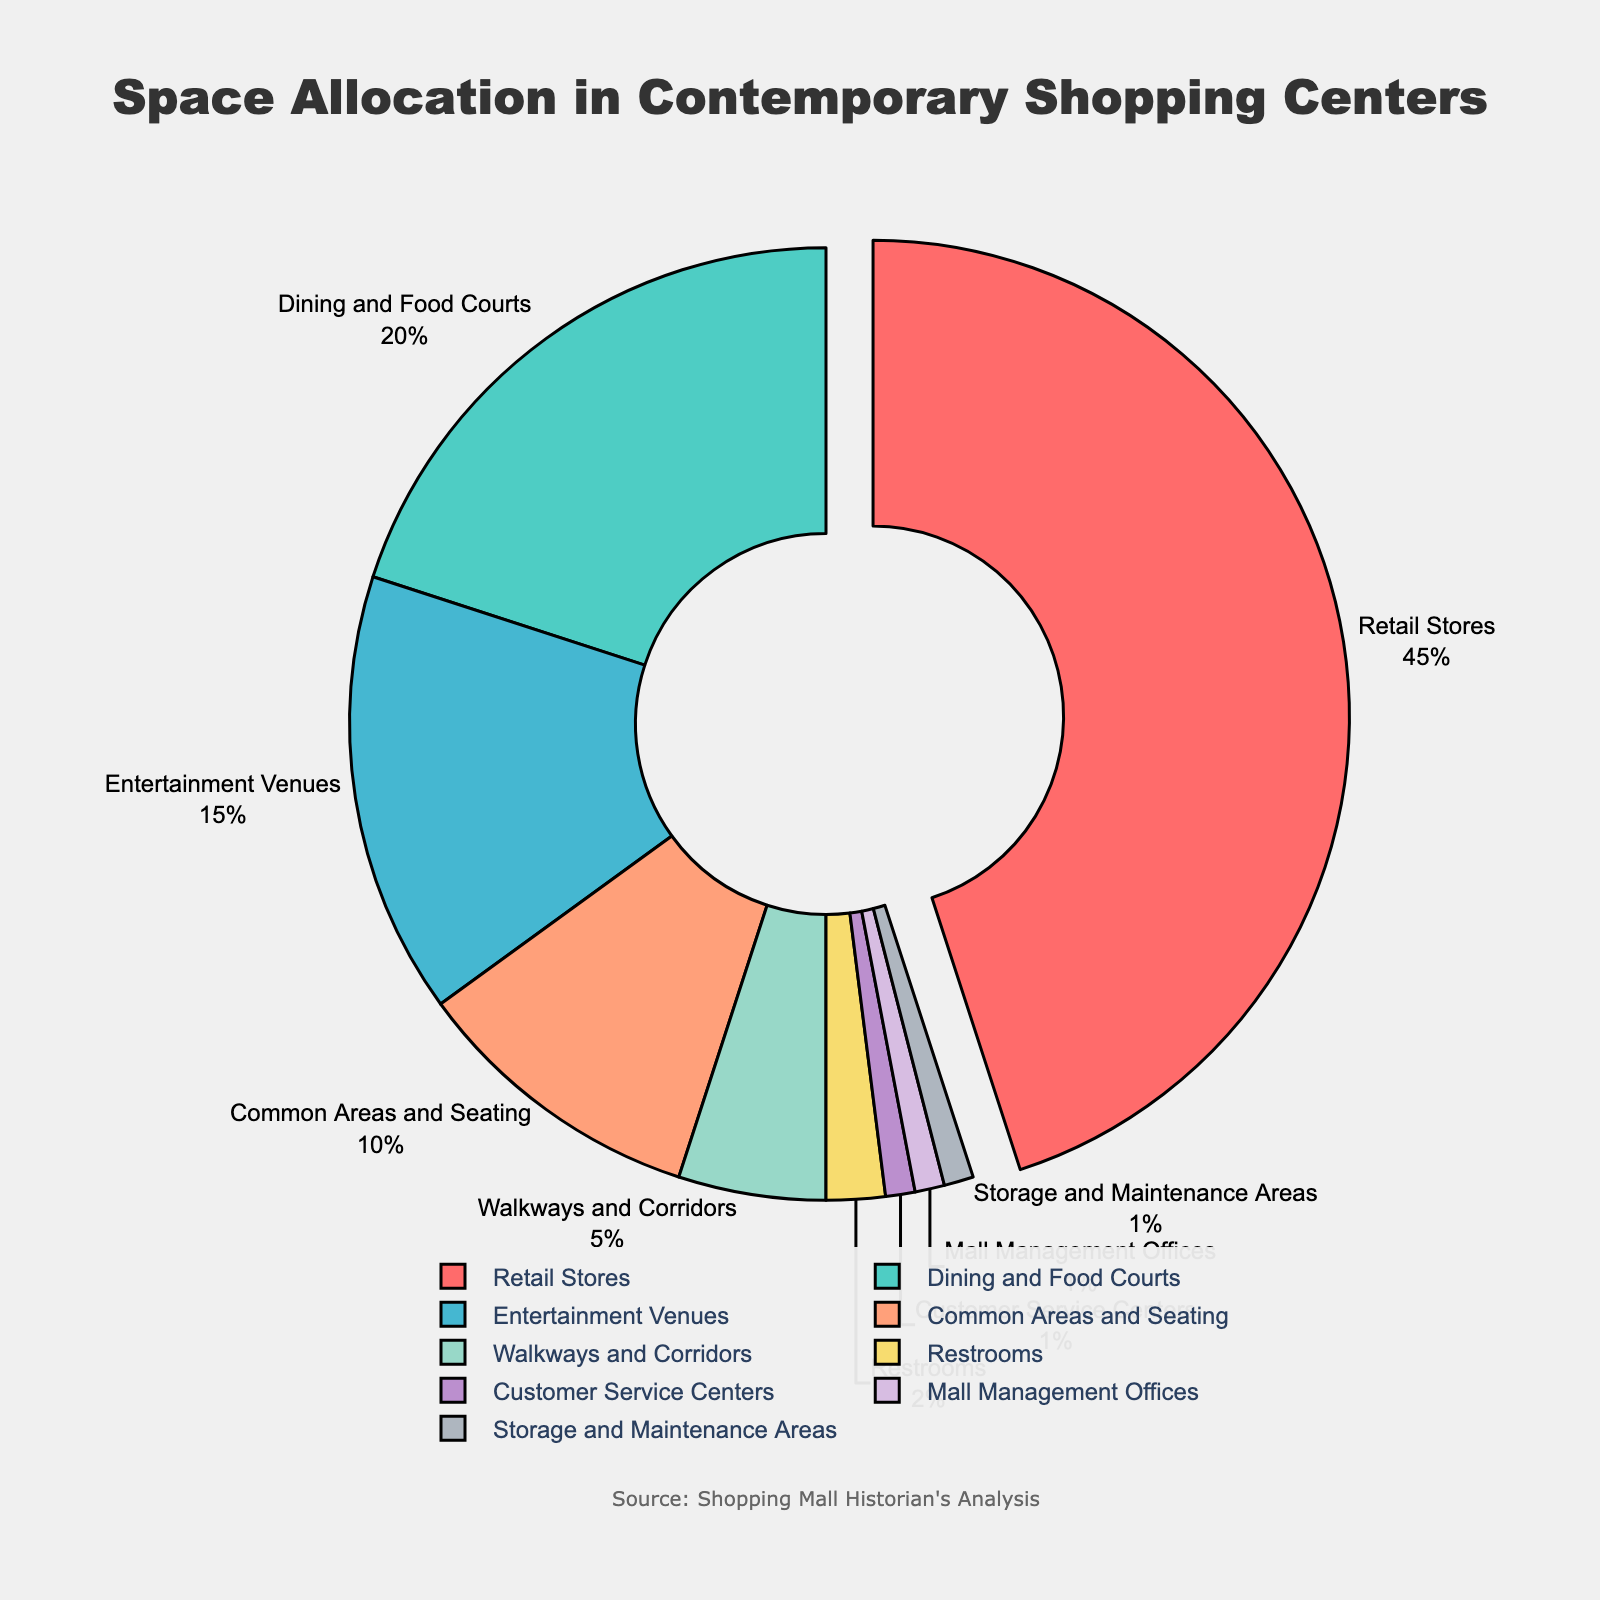How much total space is allocated to Retail Stores and Dining and Food Courts combined? From the pie chart, Retail Stores account for 45% and Dining and Food Courts take up 20%. Adding them together, 45% + 20% = 65%.
Answer: 65% Which category has the least amount of allocated space? The pie chart shows that Customer Service Centers, Mall Management Offices, and Storage and Maintenance Areas each have 1% allocated space, which is the least among all categories.
Answer: Customer Service Centers, Mall Management Offices, Storage and Maintenance Areas How does the space allocated to Entertainment Venues compare to Common Areas and Seating? The pie chart shows that Entertainment Venues have 15% allocated space, while Common Areas and Seating have 10%. Comparing these, Entertainment Venues occupy 5% more space.
Answer: Entertainment Venues have 5% more space than Common Areas and Seating What is the combined percentage of space allocated to Walkways and Corridors, Restrooms, and Customer Service Centers? From the pie chart, Walkways and Corridors have 5%, Restrooms 2%, and Customer Service Centers 1%. Adding them together, 5% + 2% + 1% = 8%.
Answer: 8% What category is represented by the largest segment that is pulled out of the pie chart? The pie chart shows that Retail Stores represent the largest segment, which is also pulled out for emphasis.
Answer: Retail Stores How does the space allocation for Dining and Food Courts compare to Entertainment Venues and Common Areas and Seating combined? Dining and Food Courts have 20% allocated space, whereas Entertainment Venues have 15% and Common Areas and Seating have 10%, combining to 15% + 10% = 25%. Dining and Food Courts have 5% less space compared to the combined Entertainment Venues and Common Areas and Seating.
Answer: Dining and Food Courts have 5% less space What is the difference between the space allocated to Walkways and Corridors and Customer Service Centers? Walkways and Corridors occupy 5%, while Customer Service Centers occupy 1%. The difference between them is 5% - 1% = 4%.
Answer: 4% If we combine the spaces allocated to Common Areas and Seating, Walkways and Corridors, and Restrooms, what fraction of the total space do they represent? Common Areas and Seating have 10%, Walkways and Corridors have 5%, and Restrooms have 2%. Adding them, 10% + 5% + 2% = 17%, which is 17/100 or 17% of the total space.
Answer: 17% 